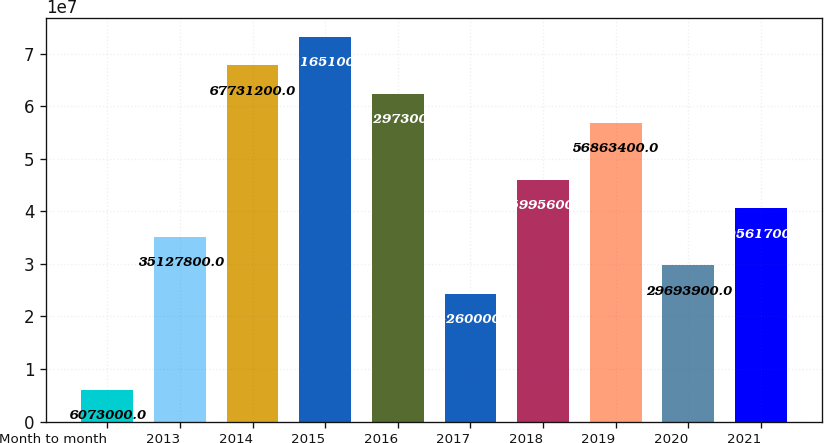Convert chart. <chart><loc_0><loc_0><loc_500><loc_500><bar_chart><fcel>Month to month<fcel>2013<fcel>2014<fcel>2015<fcel>2016<fcel>2017<fcel>2018<fcel>2019<fcel>2020<fcel>2021<nl><fcel>6.073e+06<fcel>3.51278e+07<fcel>6.77312e+07<fcel>7.31651e+07<fcel>6.22973e+07<fcel>2.426e+07<fcel>4.59956e+07<fcel>5.68634e+07<fcel>2.96939e+07<fcel>4.05617e+07<nl></chart> 